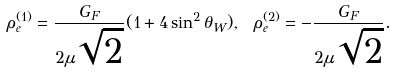Convert formula to latex. <formula><loc_0><loc_0><loc_500><loc_500>\rho _ { e } ^ { ( 1 ) } = { \frac { G _ { F } } { 2 \mu \sqrt { 2 } } } ( 1 + 4 \sin ^ { 2 } \theta _ { W } ) , \ \rho _ { e } ^ { ( 2 ) } = - { \frac { G _ { F } } { 2 \mu \sqrt { 2 } } } .</formula> 